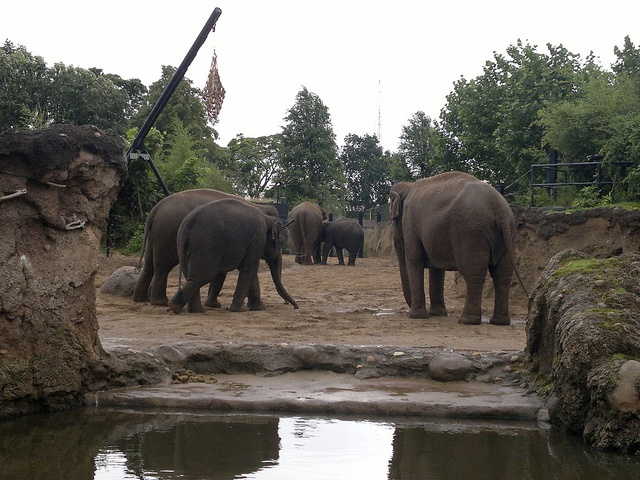Describe the objects in this image and their specific colors. I can see elephant in white, black, and gray tones, elephant in white, black, and gray tones, elephant in white, black, and gray tones, elephant in white, black, and gray tones, and elephant in white, black, and gray tones in this image. 